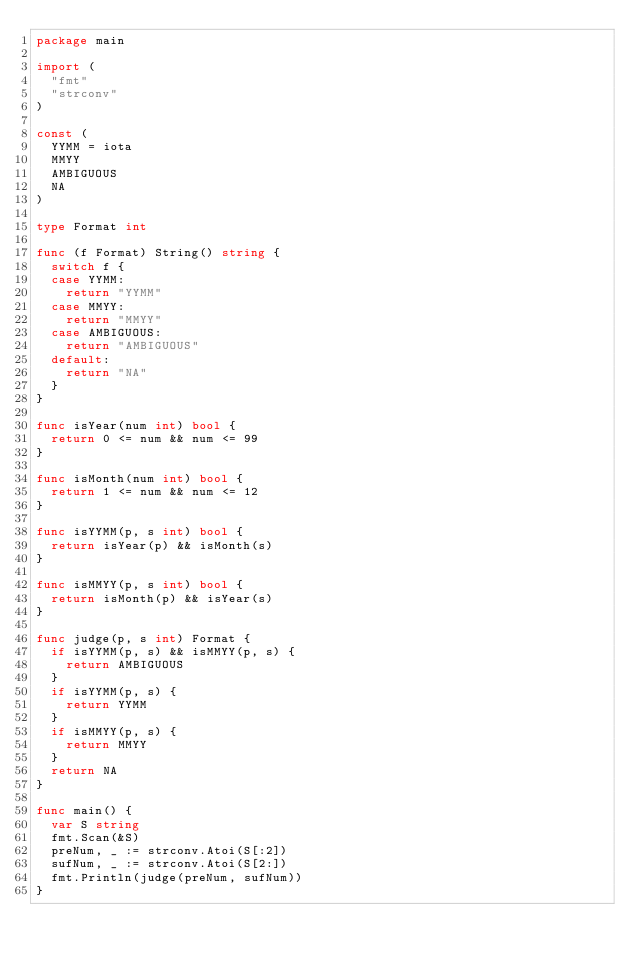Convert code to text. <code><loc_0><loc_0><loc_500><loc_500><_Go_>package main

import (
	"fmt"
	"strconv"
)

const (
	YYMM = iota
	MMYY
	AMBIGUOUS
	NA
)

type Format int

func (f Format) String() string {
	switch f {
	case YYMM:
		return "YYMM"
	case MMYY:
		return "MMYY"
	case AMBIGUOUS:
		return "AMBIGUOUS"
	default:
		return "NA"
	}
}

func isYear(num int) bool {
	return 0 <= num && num <= 99
}

func isMonth(num int) bool {
	return 1 <= num && num <= 12
}

func isYYMM(p, s int) bool {
	return isYear(p) && isMonth(s)
}

func isMMYY(p, s int) bool {
	return isMonth(p) && isYear(s)
}

func judge(p, s int) Format {
	if isYYMM(p, s) && isMMYY(p, s) {
		return AMBIGUOUS
	}
	if isYYMM(p, s) {
		return YYMM
	}
	if isMMYY(p, s) {
		return MMYY
	}
	return NA
}

func main() {
	var S string
	fmt.Scan(&S)
	preNum, _ := strconv.Atoi(S[:2])
	sufNum, _ := strconv.Atoi(S[2:])
	fmt.Println(judge(preNum, sufNum))
}
</code> 